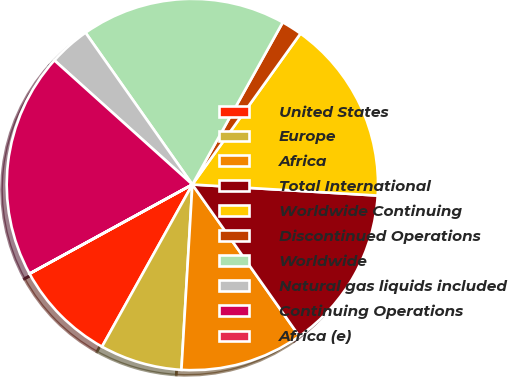Convert chart to OTSL. <chart><loc_0><loc_0><loc_500><loc_500><pie_chart><fcel>United States<fcel>Europe<fcel>Africa<fcel>Total International<fcel>Worldwide Continuing<fcel>Discontinued Operations<fcel>Worldwide<fcel>Natural gas liquids included<fcel>Continuing Operations<fcel>Africa (e)<nl><fcel>8.93%<fcel>7.15%<fcel>10.71%<fcel>14.28%<fcel>16.06%<fcel>1.8%<fcel>17.85%<fcel>3.58%<fcel>19.63%<fcel>0.01%<nl></chart> 